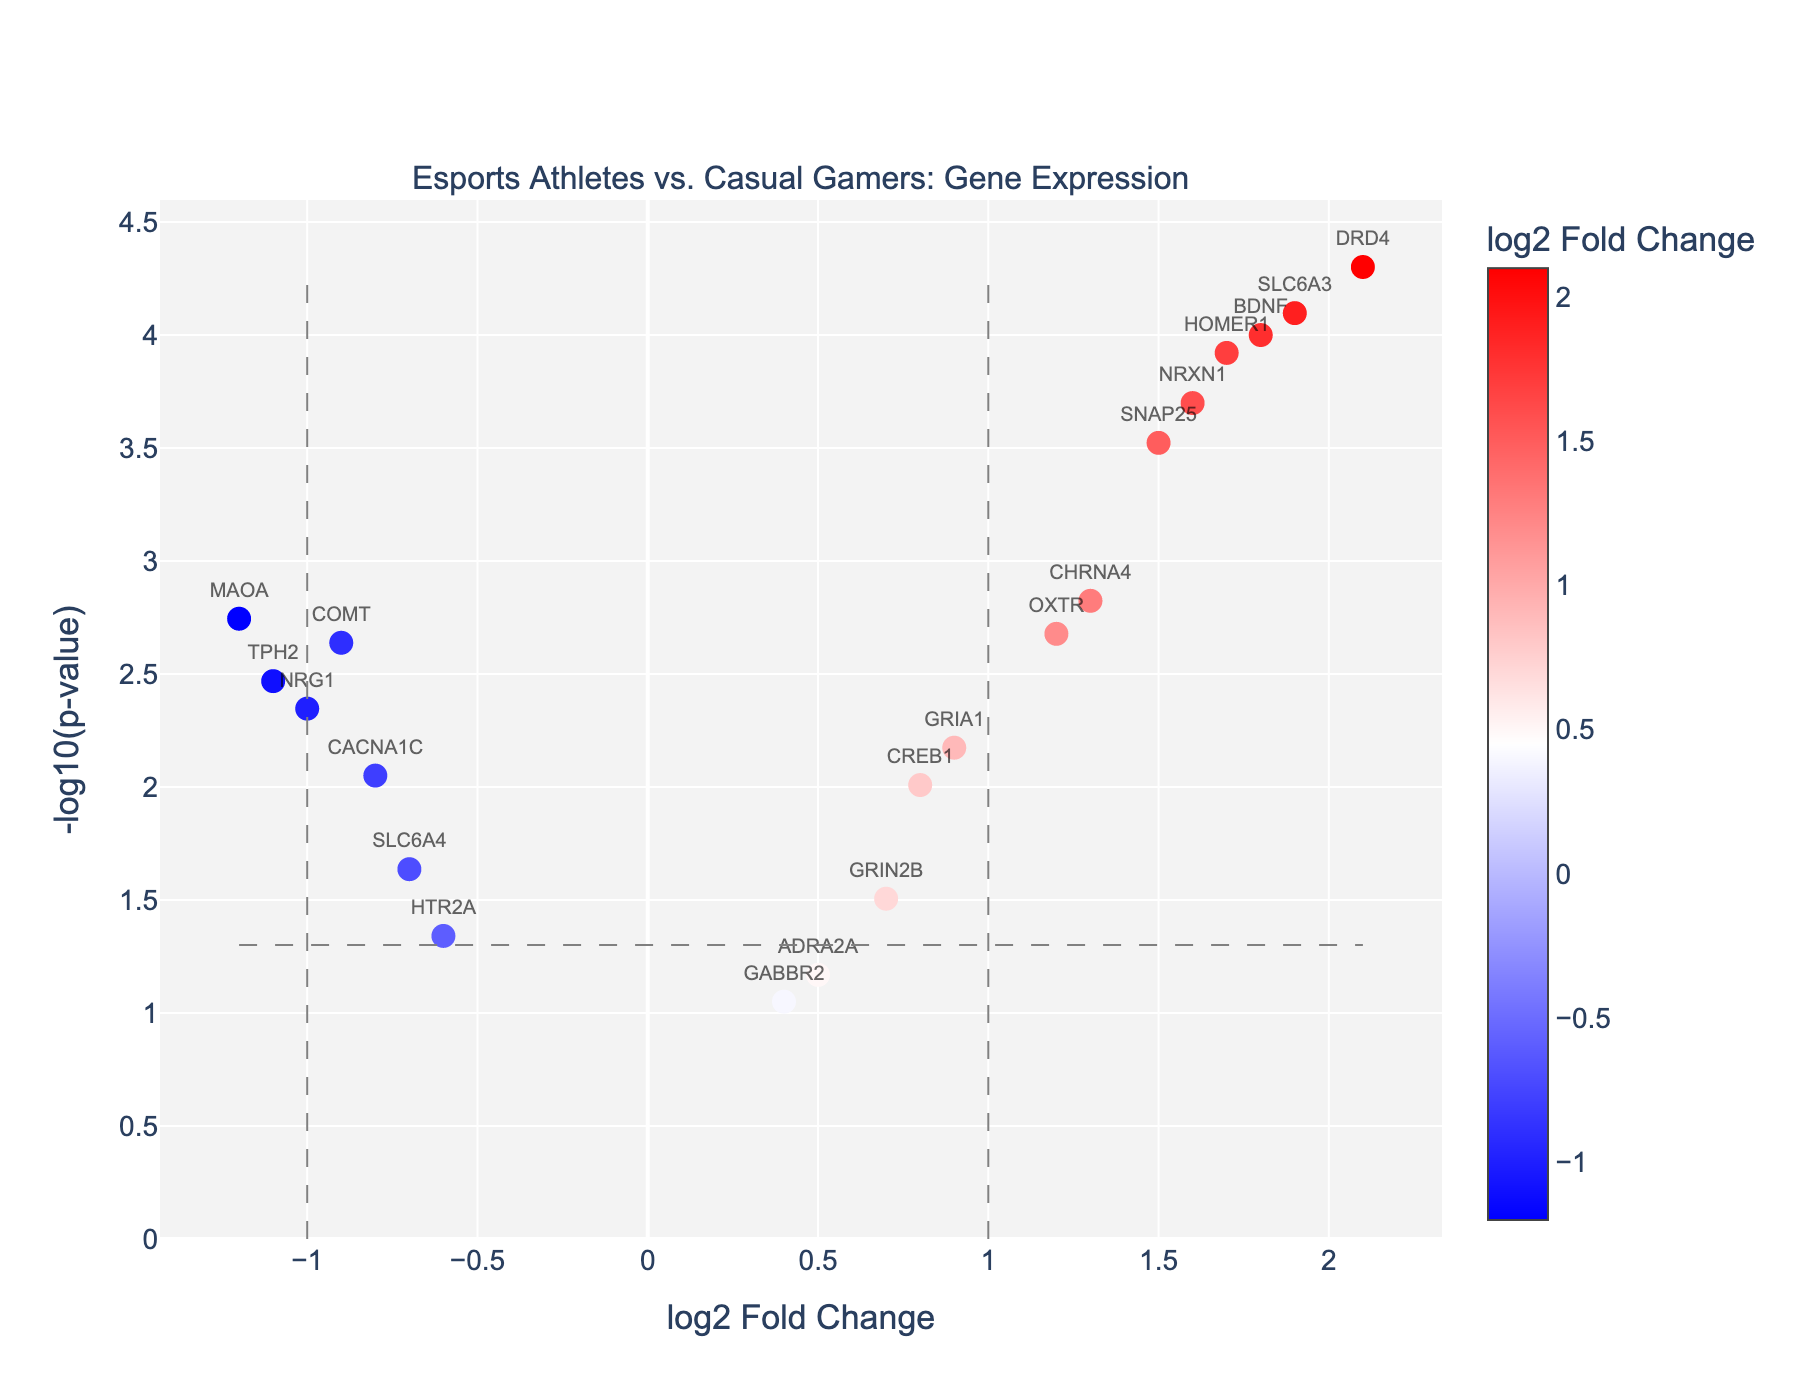How many genes show significant differential expression t? The number of genes can be determined by considering those points that lie above the -log10(p-value) threshold line of -log10(0.05) (~1.3).
Answer: 18 Which gene has the highest positive log2 fold change? By examining the x-axis representing the log2 fold change, the gene with the highest value is identified.
Answer: DRD4 Which gene has the highest negative log2 fold change? By checking the extreme left end of the x-axis, the gene with the most negative fold change is identified.
Answer: MAOA Which gene has the lowest p-value? By finding the point that is highest on the y-axis, corresponding to -log10(p-value), this gene is identified.
Answer: DRD4 What is the threshold value for considering a gene significantly expressed? This value is marked by the horizontal line on the y-axis at -log10(p-value) = 1.3, corresponding to p-value = 0.05.
Answer: p-value = 0.05 How many genes have a log2 fold change greater than 1? By counting the points to the right of the vertical line at log2 fold change = 1 on the x-axis, the number is determined.
Answer: 6 What is the log2 fold change and p-value for gene BDNF? By locating the point labeled BDNF and examining the hover text in the plot, the values are found.
Answer: log2FC: 1.8, p-value: 0.0001 Which genes related to reflexes have more than two-fold change? Based on the data provided, genes above the threshold fold change (log2FC > 1 or log2FC < -1) are checked for significance.
Answer: DRD4, SLC6A3, BDNF, HOMER1 Compare the log2 fold change of BDNF and COMT. Which one is higher? By looking at both the x-axis values for BDNF (1.8) and COMT (-0.9) and comparing, BDNF is higher.
Answer: BDNF 